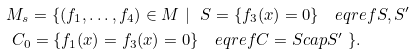Convert formula to latex. <formula><loc_0><loc_0><loc_500><loc_500>& M _ { s } = \{ ( f _ { 1 } , \dots , f _ { 4 } ) \in M \ | \ \ S = \{ f _ { 3 } ( x ) = 0 \} \quad e q r e f { S , S ^ { \prime } } \\ & \ C _ { 0 } = \{ f _ { 1 } ( x ) = f _ { 3 } ( x ) = 0 \} \quad e q r e f { C = S c a p S ^ { \prime } } \ \} .</formula> 